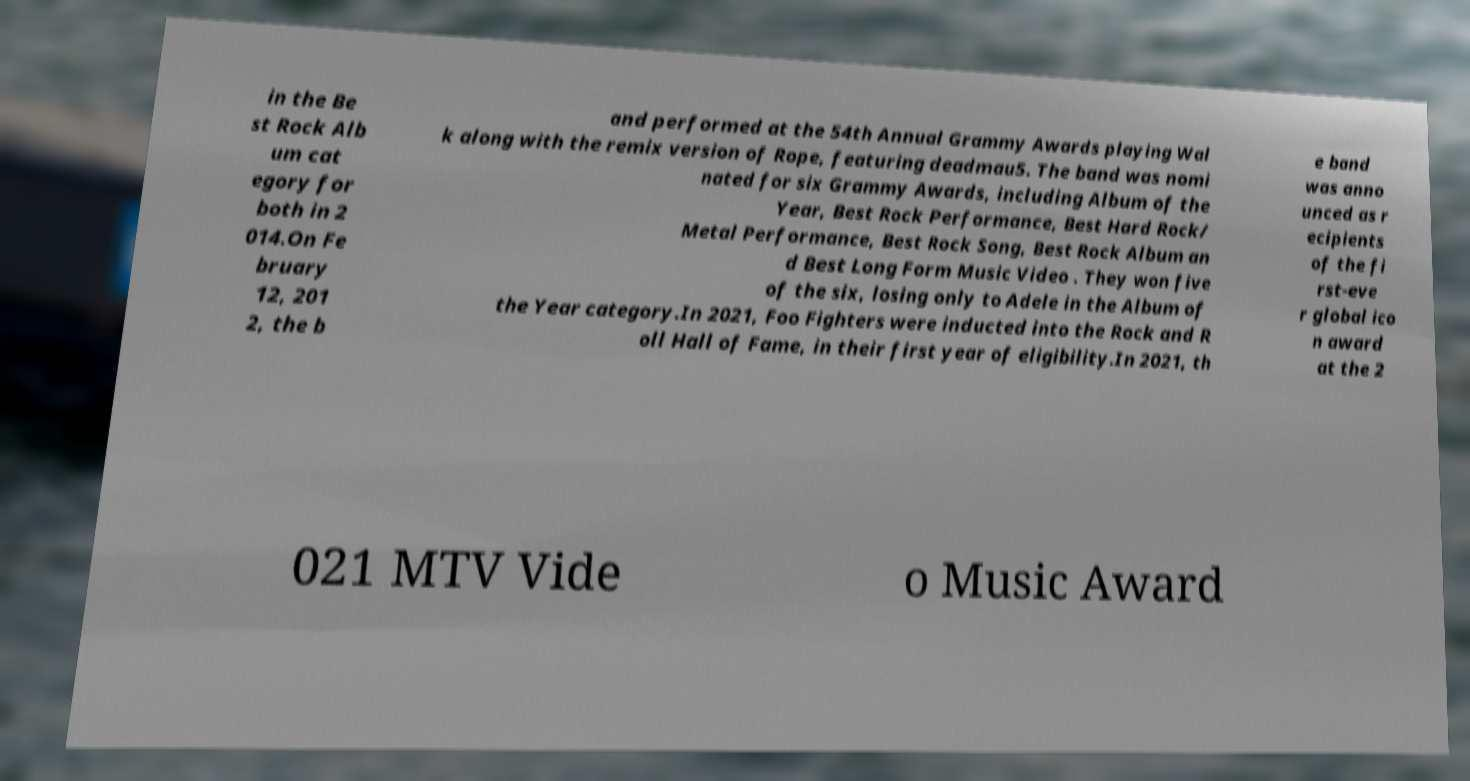Could you assist in decoding the text presented in this image and type it out clearly? in the Be st Rock Alb um cat egory for both in 2 014.On Fe bruary 12, 201 2, the b and performed at the 54th Annual Grammy Awards playing Wal k along with the remix version of Rope, featuring deadmau5. The band was nomi nated for six Grammy Awards, including Album of the Year, Best Rock Performance, Best Hard Rock/ Metal Performance, Best Rock Song, Best Rock Album an d Best Long Form Music Video . They won five of the six, losing only to Adele in the Album of the Year category.In 2021, Foo Fighters were inducted into the Rock and R oll Hall of Fame, in their first year of eligibility.In 2021, th e band was anno unced as r ecipients of the fi rst-eve r global ico n award at the 2 021 MTV Vide o Music Award 